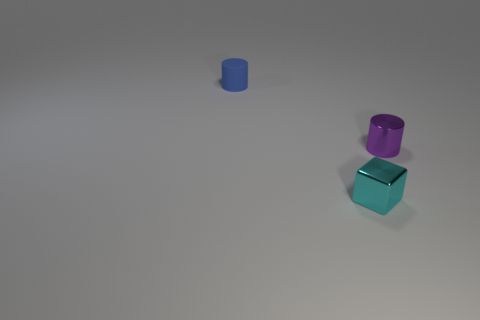Add 1 large red metallic cylinders. How many objects exist? 4 Subtract all purple cylinders. How many cylinders are left? 1 Subtract all cubes. How many objects are left? 2 Subtract all yellow balls. How many green blocks are left? 0 Subtract all blue shiny things. Subtract all tiny purple cylinders. How many objects are left? 2 Add 3 small cubes. How many small cubes are left? 4 Add 1 shiny cylinders. How many shiny cylinders exist? 2 Subtract 1 cyan blocks. How many objects are left? 2 Subtract all gray cylinders. Subtract all green cubes. How many cylinders are left? 2 